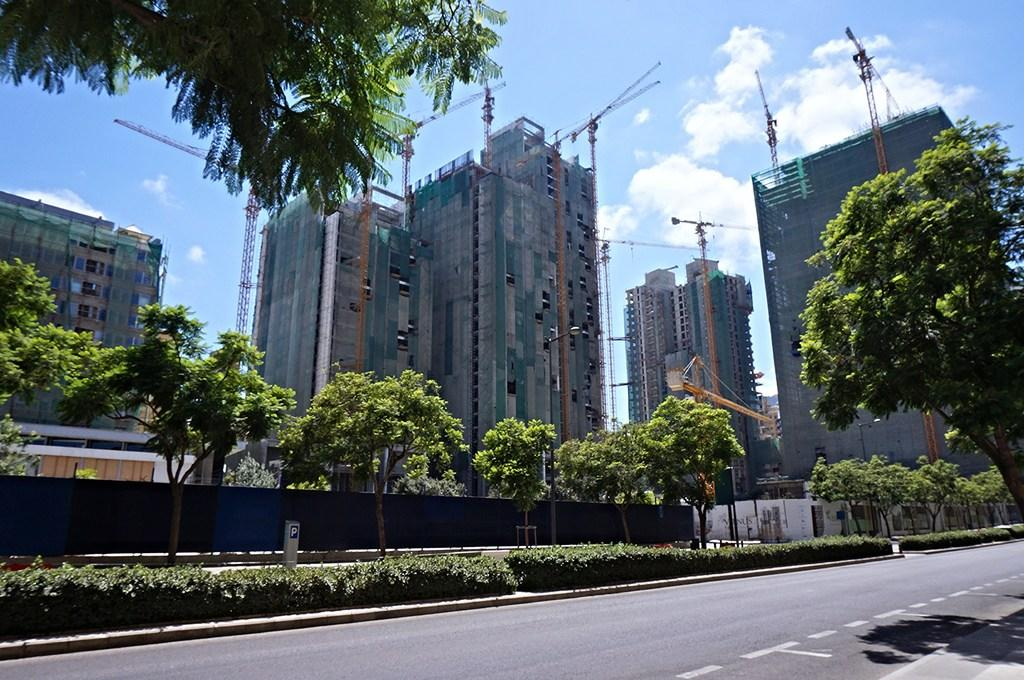What is happening in the image? There are huge buildings being constructed in the image. What can be seen on the footpath in the image? There are trees and bushes on the footpath in the image. What is located beside the footpath in the image? There is a road beside the footpath in the image. What type of minute is visible in the image? There are no minutes present in the image; it features buildings under construction, trees and bushes on the footpath, and a road beside the footpath. 